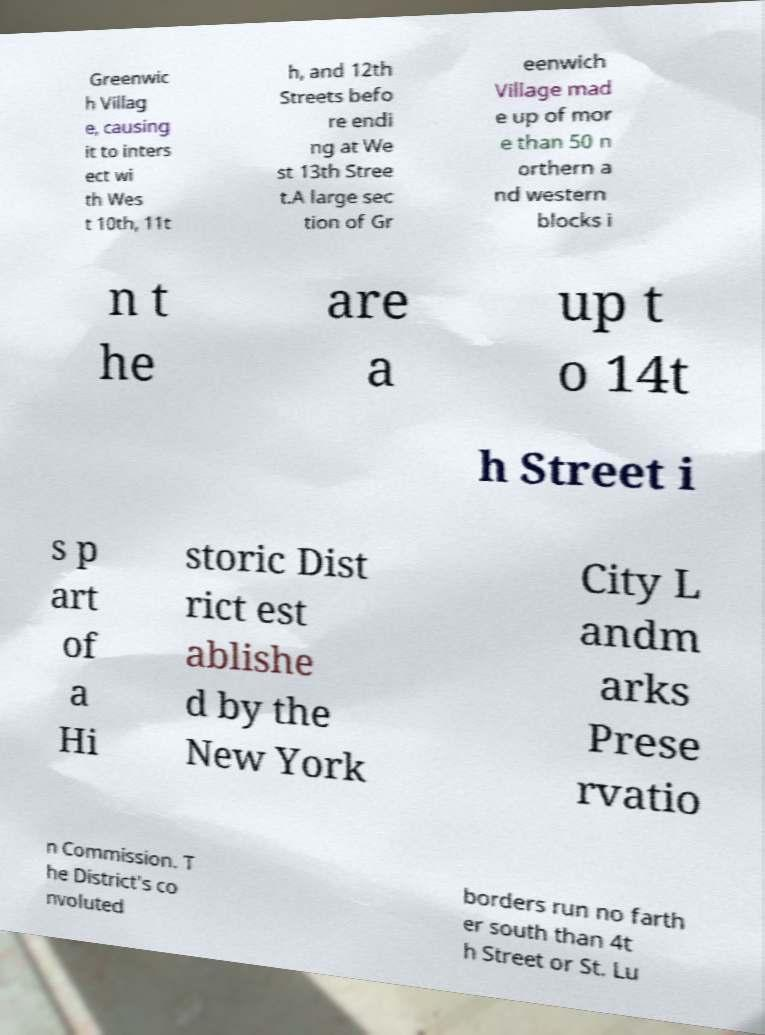Could you assist in decoding the text presented in this image and type it out clearly? Greenwic h Villag e, causing it to inters ect wi th Wes t 10th, 11t h, and 12th Streets befo re endi ng at We st 13th Stree t.A large sec tion of Gr eenwich Village mad e up of mor e than 50 n orthern a nd western blocks i n t he are a up t o 14t h Street i s p art of a Hi storic Dist rict est ablishe d by the New York City L andm arks Prese rvatio n Commission. T he District's co nvoluted borders run no farth er south than 4t h Street or St. Lu 